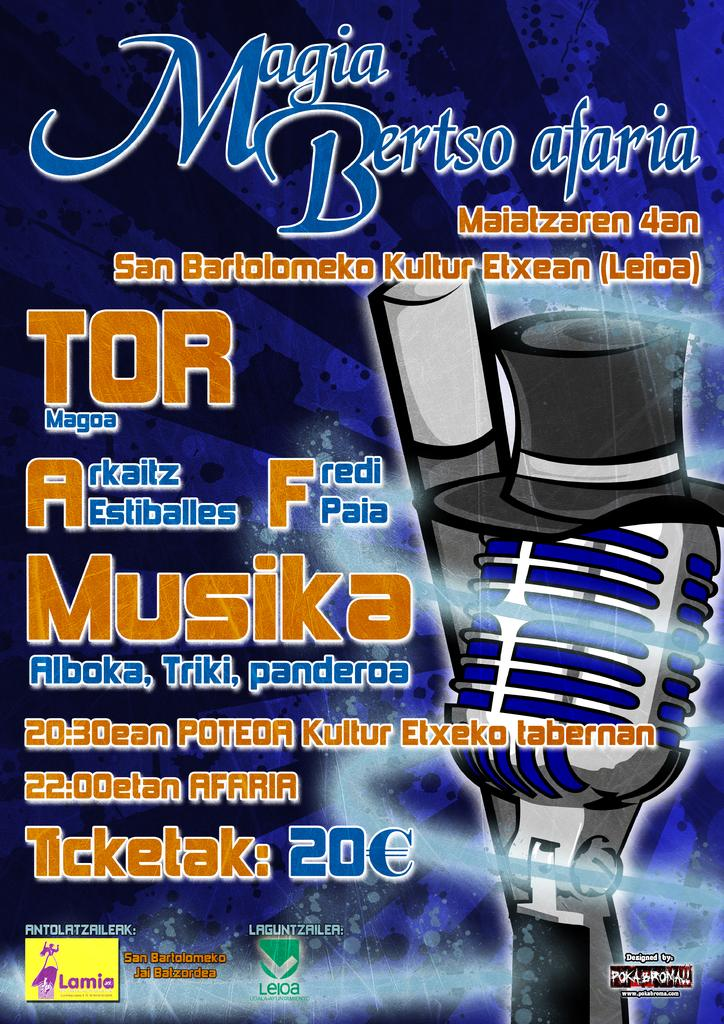<image>
Share a concise interpretation of the image provided. Poster for Magia Bertso Afaria with a microphone on the front. 